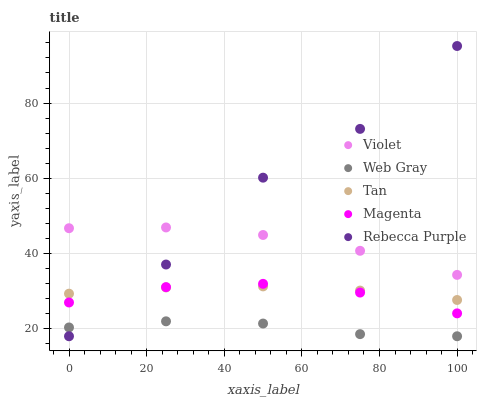Does Web Gray have the minimum area under the curve?
Answer yes or no. Yes. Does Rebecca Purple have the maximum area under the curve?
Answer yes or no. Yes. Does Magenta have the minimum area under the curve?
Answer yes or no. No. Does Magenta have the maximum area under the curve?
Answer yes or no. No. Is Tan the smoothest?
Answer yes or no. Yes. Is Rebecca Purple the roughest?
Answer yes or no. Yes. Is Web Gray the smoothest?
Answer yes or no. No. Is Web Gray the roughest?
Answer yes or no. No. Does Web Gray have the lowest value?
Answer yes or no. Yes. Does Magenta have the lowest value?
Answer yes or no. No. Does Rebecca Purple have the highest value?
Answer yes or no. Yes. Does Magenta have the highest value?
Answer yes or no. No. Is Web Gray less than Tan?
Answer yes or no. Yes. Is Violet greater than Web Gray?
Answer yes or no. Yes. Does Violet intersect Rebecca Purple?
Answer yes or no. Yes. Is Violet less than Rebecca Purple?
Answer yes or no. No. Is Violet greater than Rebecca Purple?
Answer yes or no. No. Does Web Gray intersect Tan?
Answer yes or no. No. 